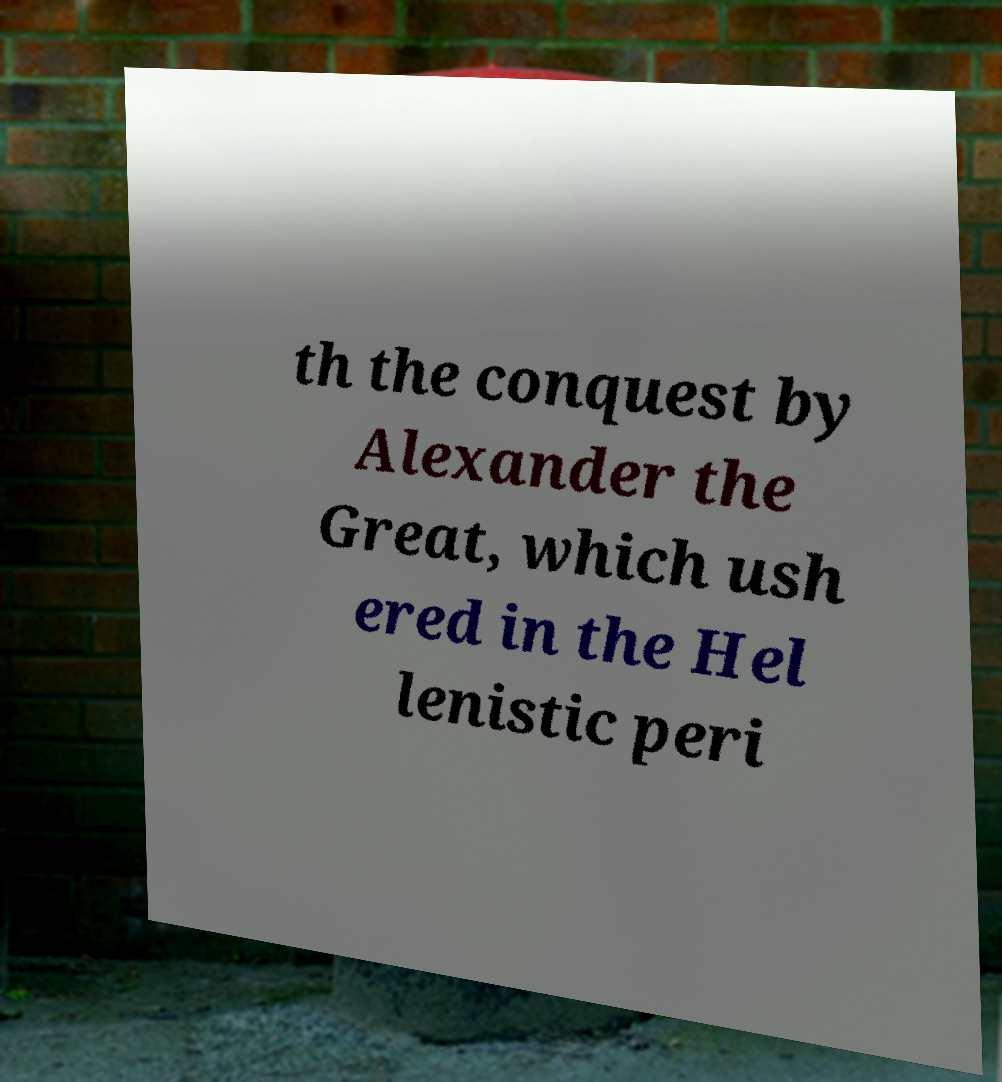For documentation purposes, I need the text within this image transcribed. Could you provide that? th the conquest by Alexander the Great, which ush ered in the Hel lenistic peri 